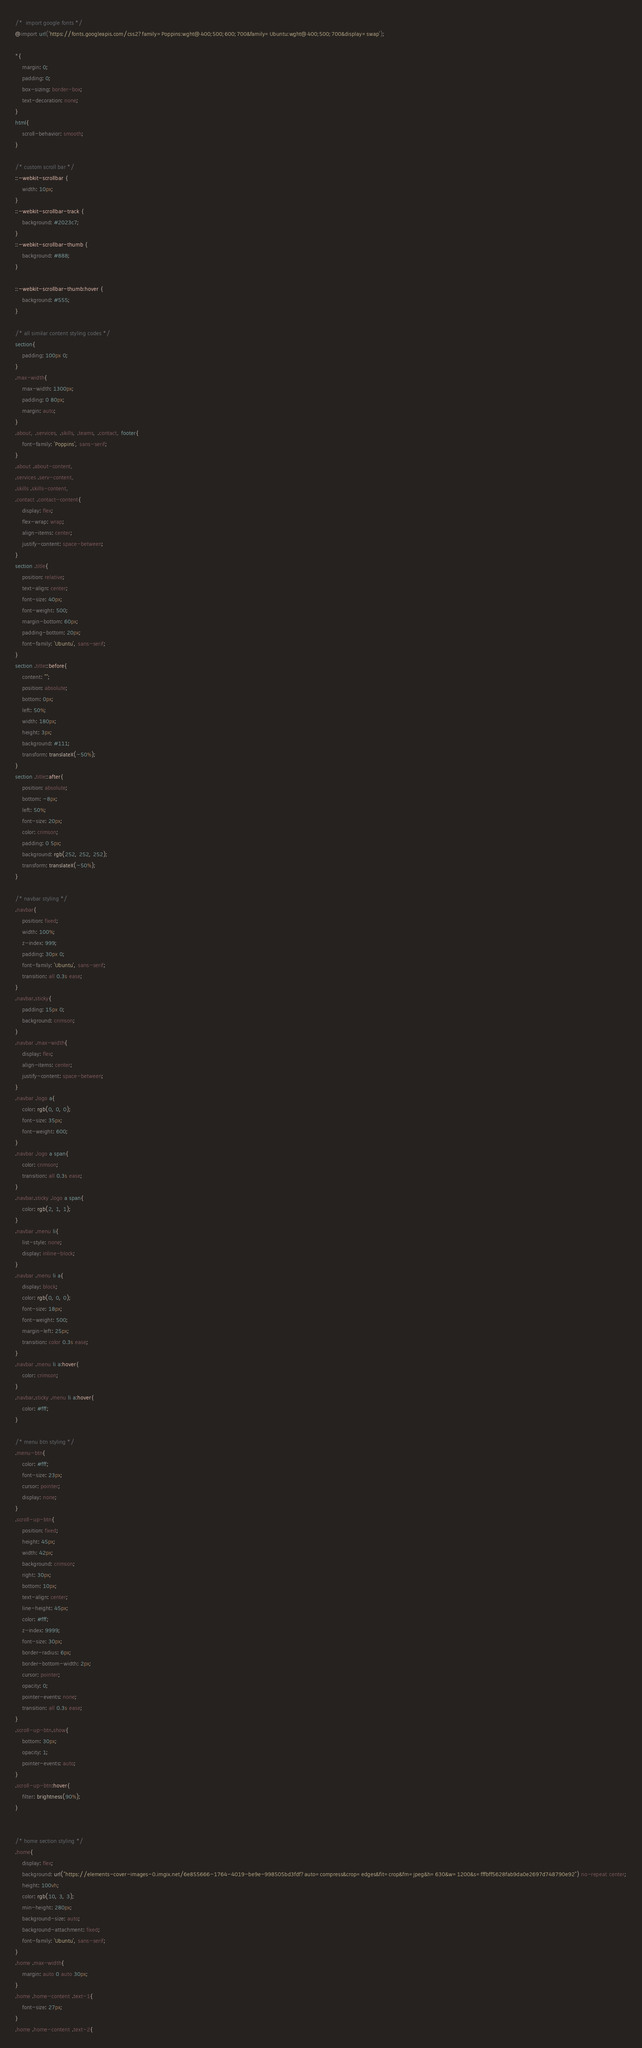Convert code to text. <code><loc_0><loc_0><loc_500><loc_500><_CSS_>/*  import google fonts */
@import url('https://fonts.googleapis.com/css2?family=Poppins:wght@400;500;600;700&family=Ubuntu:wght@400;500;700&display=swap');

*{
    margin: 0;
    padding: 0;
    box-sizing: border-box;
    text-decoration: none;
}
html{
    scroll-behavior: smooth;
}

/* custom scroll bar */
::-webkit-scrollbar {
    width: 10px;
}
::-webkit-scrollbar-track {
    background: #2023c7;
}
::-webkit-scrollbar-thumb {
    background: #888;
}

::-webkit-scrollbar-thumb:hover {
    background: #555;
}

/* all similar content styling codes */
section{
    padding: 100px 0;
}
.max-width{
    max-width: 1300px;
    padding: 0 80px;
    margin: auto;
}
.about, .services, .skills, .teams, .contact, footer{
    font-family: 'Poppins', sans-serif;
}
.about .about-content, 
.services .serv-content,
.skills .skills-content,
.contact .contact-content{
    display: flex;
    flex-wrap: wrap;
    align-items: center;
    justify-content: space-between;
}
section .title{
    position: relative;
    text-align: center;
    font-size: 40px;
    font-weight: 500;
    margin-bottom: 60px;
    padding-bottom: 20px;
    font-family: 'Ubuntu', sans-serif;
}
section .title::before{
    content: "";
    position: absolute;
    bottom: 0px;
    left: 50%;
    width: 180px;
    height: 3px;
    background: #111;
    transform: translateX(-50%);
}
section .title::after{
    position: absolute;
    bottom: -8px;
    left: 50%;
    font-size: 20px;
    color: crimson;
    padding: 0 5px;
    background: rgb(252, 252, 252);
    transform: translateX(-50%);
}

/* navbar styling */
.navbar{
    position: fixed;
    width: 100%;
    z-index: 999;
    padding: 30px 0;
    font-family: 'Ubuntu', sans-serif;
    transition: all 0.3s ease;
}
.navbar.sticky{
    padding: 15px 0;
    background: crimson;
}
.navbar .max-width{
    display: flex;
    align-items: center;
    justify-content: space-between;
}
.navbar .logo a{
    color: rgb(0, 0, 0);
    font-size: 35px;
    font-weight: 600;
}
.navbar .logo a span{
    color: crimson;
    transition: all 0.3s ease;
}
.navbar.sticky .logo a span{
    color: rgb(2, 1, 1);
}
.navbar .menu li{
    list-style: none;
    display: inline-block;
}
.navbar .menu li a{
    display: block;
    color: rgb(0, 0, 0);
    font-size: 18px;
    font-weight: 500;
    margin-left: 25px;
    transition: color 0.3s ease;
}
.navbar .menu li a:hover{
    color: crimson;
}
.navbar.sticky .menu li a:hover{
    color: #fff;
}

/* menu btn styling */
.menu-btn{
    color: #fff;
    font-size: 23px;
    cursor: pointer;
    display: none;
}
.scroll-up-btn{
    position: fixed;
    height: 45px;
    width: 42px;
    background: crimson;
    right: 30px;
    bottom: 10px;
    text-align: center;
    line-height: 45px;
    color: #fff;
    z-index: 9999;
    font-size: 30px;
    border-radius: 6px;
    border-bottom-width: 2px;
    cursor: pointer;
    opacity: 0;
    pointer-events: none;
    transition: all 0.3s ease;
}
.scroll-up-btn.show{
    bottom: 30px;
    opacity: 1;
    pointer-events: auto;
}
.scroll-up-btn:hover{
    filter: brightness(90%);
}

  
/* home section styling */
.home{
    display: flex;
    background: url("https://elements-cover-images-0.imgix.net/6e855666-1764-4019-be9e-998505bd3fdf?auto=compress&crop=edges&fit=crop&fm=jpeg&h=630&w=1200&s=fffbff5628fab9da0e2697d748790e92") no-repeat center;
    height: 100vh;
    color: rgb(10, 3, 3);
    min-height: 280px;
    background-size: auto;
    background-attachment: fixed;
    font-family: 'Ubuntu', sans-serif;
}
.home .max-width{
    margin: auto 0 auto 30px;
}
.home .home-content .text-1{
    font-size: 27px;
}
.home .home-content .text-2{</code> 